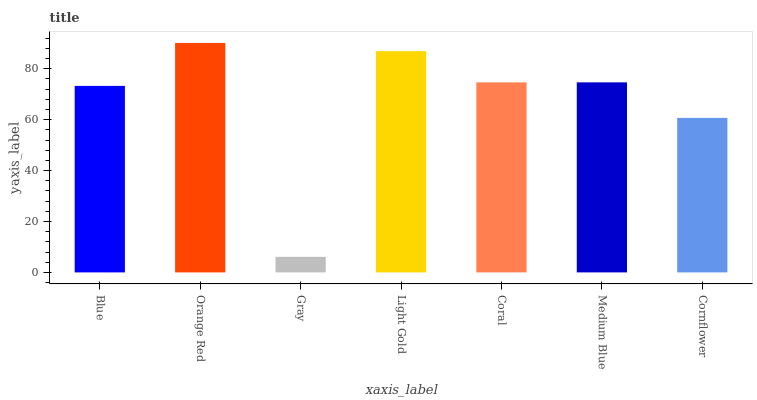Is Orange Red the minimum?
Answer yes or no. No. Is Gray the maximum?
Answer yes or no. No. Is Orange Red greater than Gray?
Answer yes or no. Yes. Is Gray less than Orange Red?
Answer yes or no. Yes. Is Gray greater than Orange Red?
Answer yes or no. No. Is Orange Red less than Gray?
Answer yes or no. No. Is Coral the high median?
Answer yes or no. Yes. Is Coral the low median?
Answer yes or no. Yes. Is Gray the high median?
Answer yes or no. No. Is Cornflower the low median?
Answer yes or no. No. 